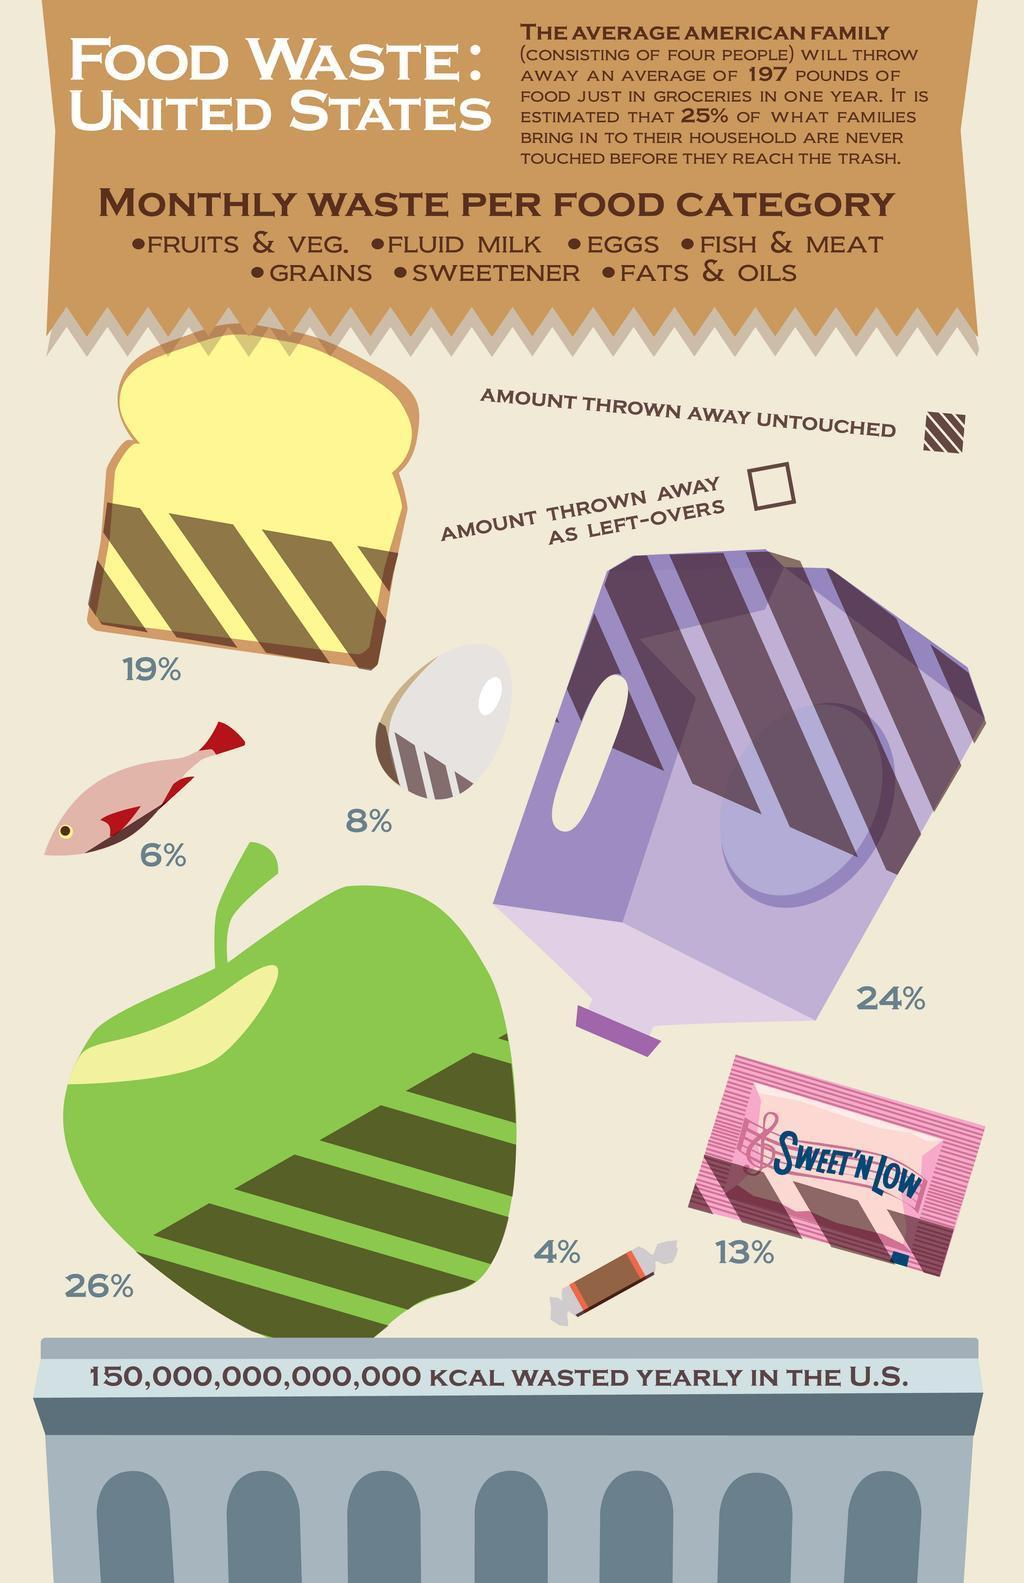8% of which food item is thrown away untouched- milk, egg or fish?
Answer the question with a short phrase. egg What percent of bread is thrown away untouched? 19% Which sweetener is shown in the infographic? SWEET'N LOW What percent of milk is thrown away as left-overs? 76% 